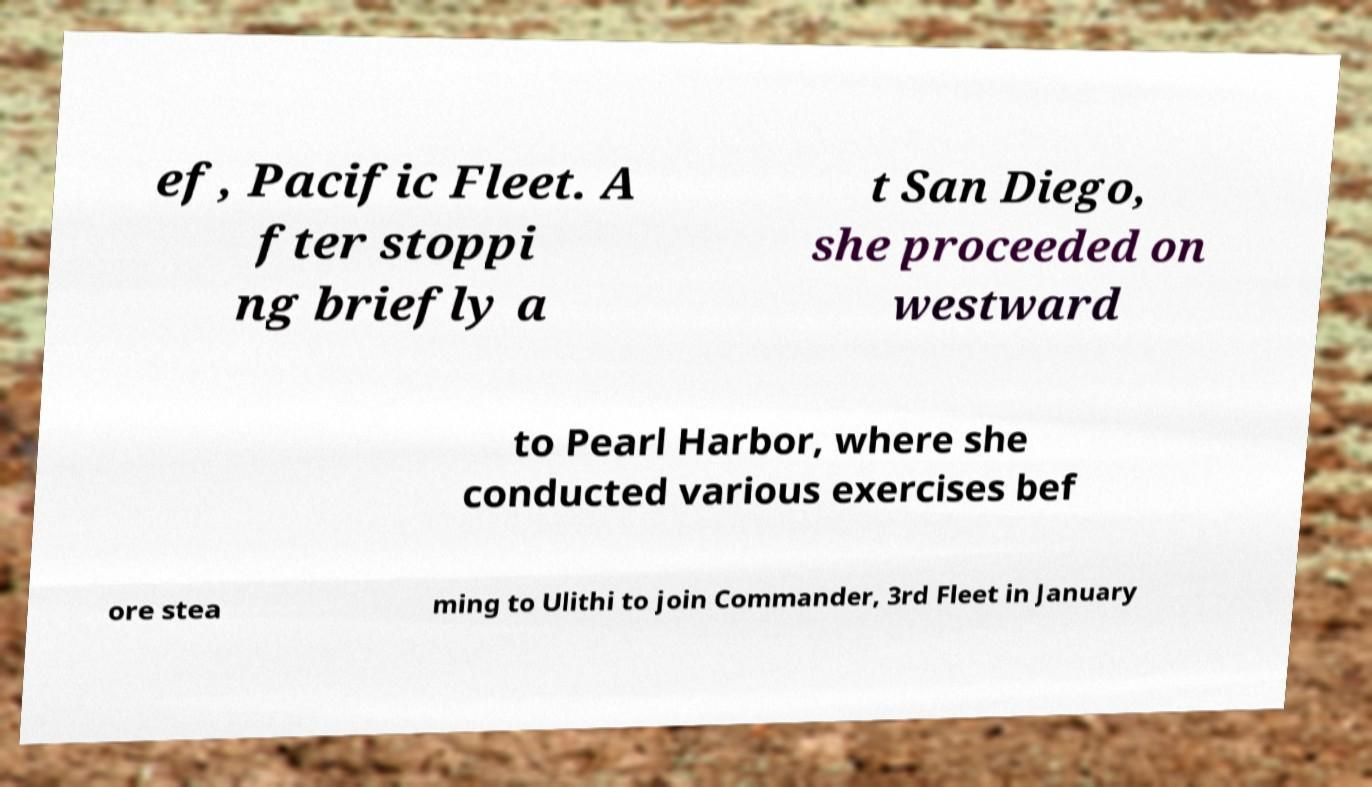What messages or text are displayed in this image? I need them in a readable, typed format. ef, Pacific Fleet. A fter stoppi ng briefly a t San Diego, she proceeded on westward to Pearl Harbor, where she conducted various exercises bef ore stea ming to Ulithi to join Commander, 3rd Fleet in January 